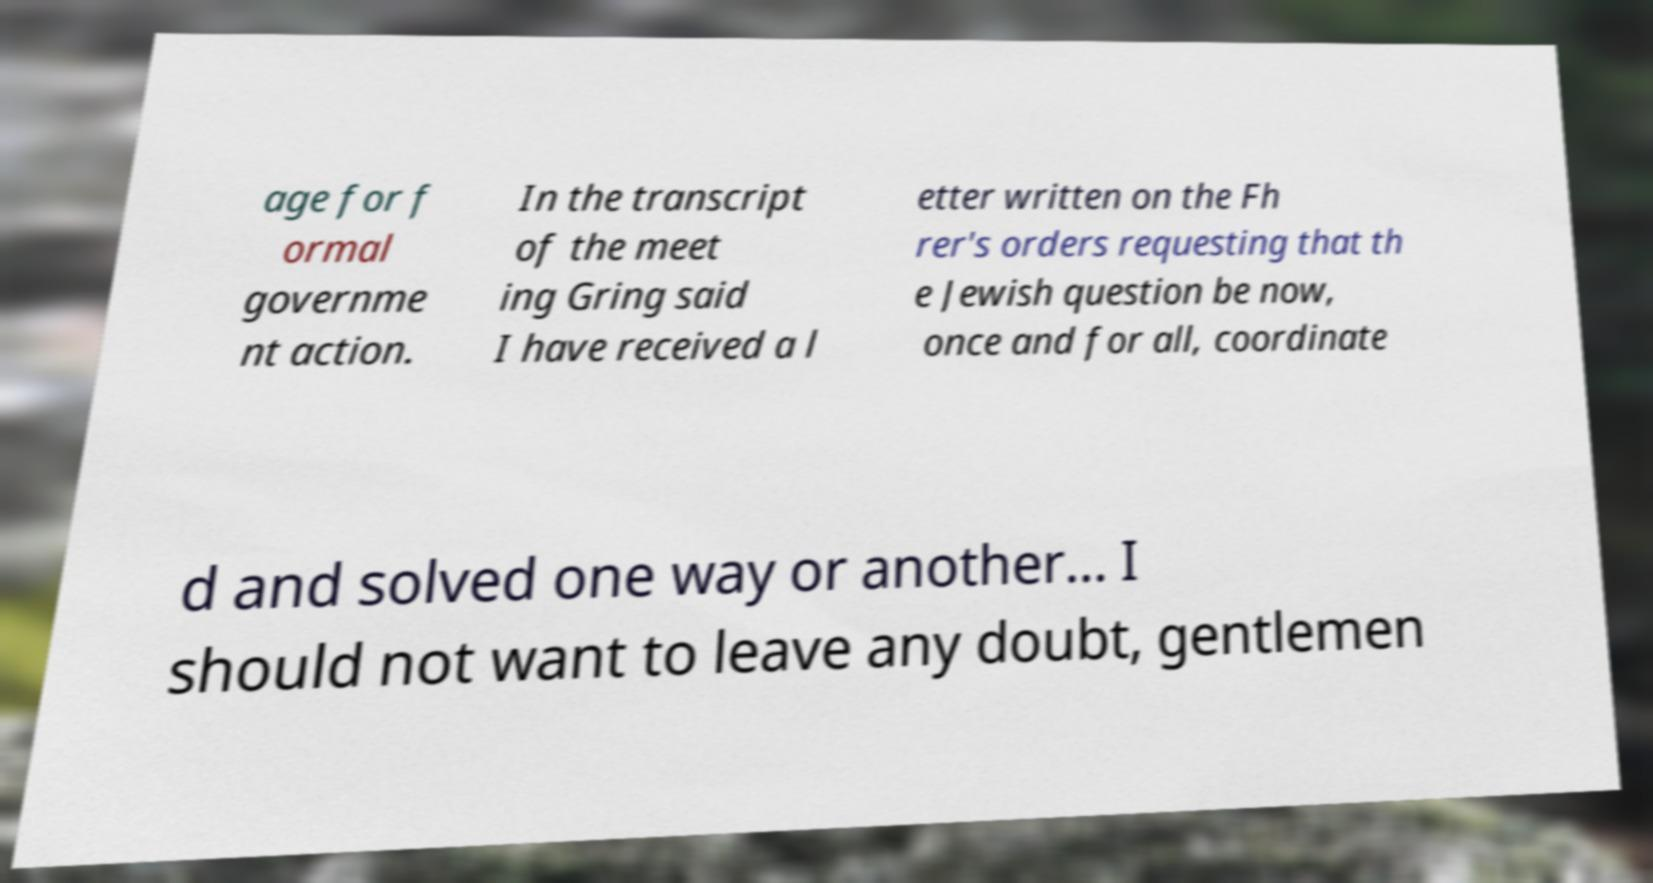There's text embedded in this image that I need extracted. Can you transcribe it verbatim? age for f ormal governme nt action. In the transcript of the meet ing Gring said I have received a l etter written on the Fh rer's orders requesting that th e Jewish question be now, once and for all, coordinate d and solved one way or another... I should not want to leave any doubt, gentlemen 